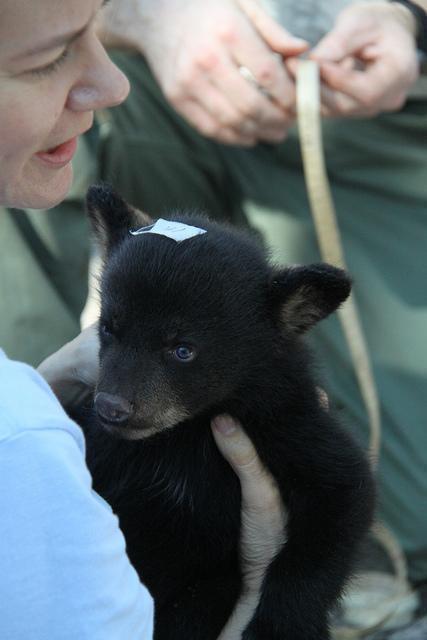How many people can you see?
Give a very brief answer. 2. How many bears are in the picture?
Give a very brief answer. 1. How many of the frisbees are in the air?
Give a very brief answer. 0. 